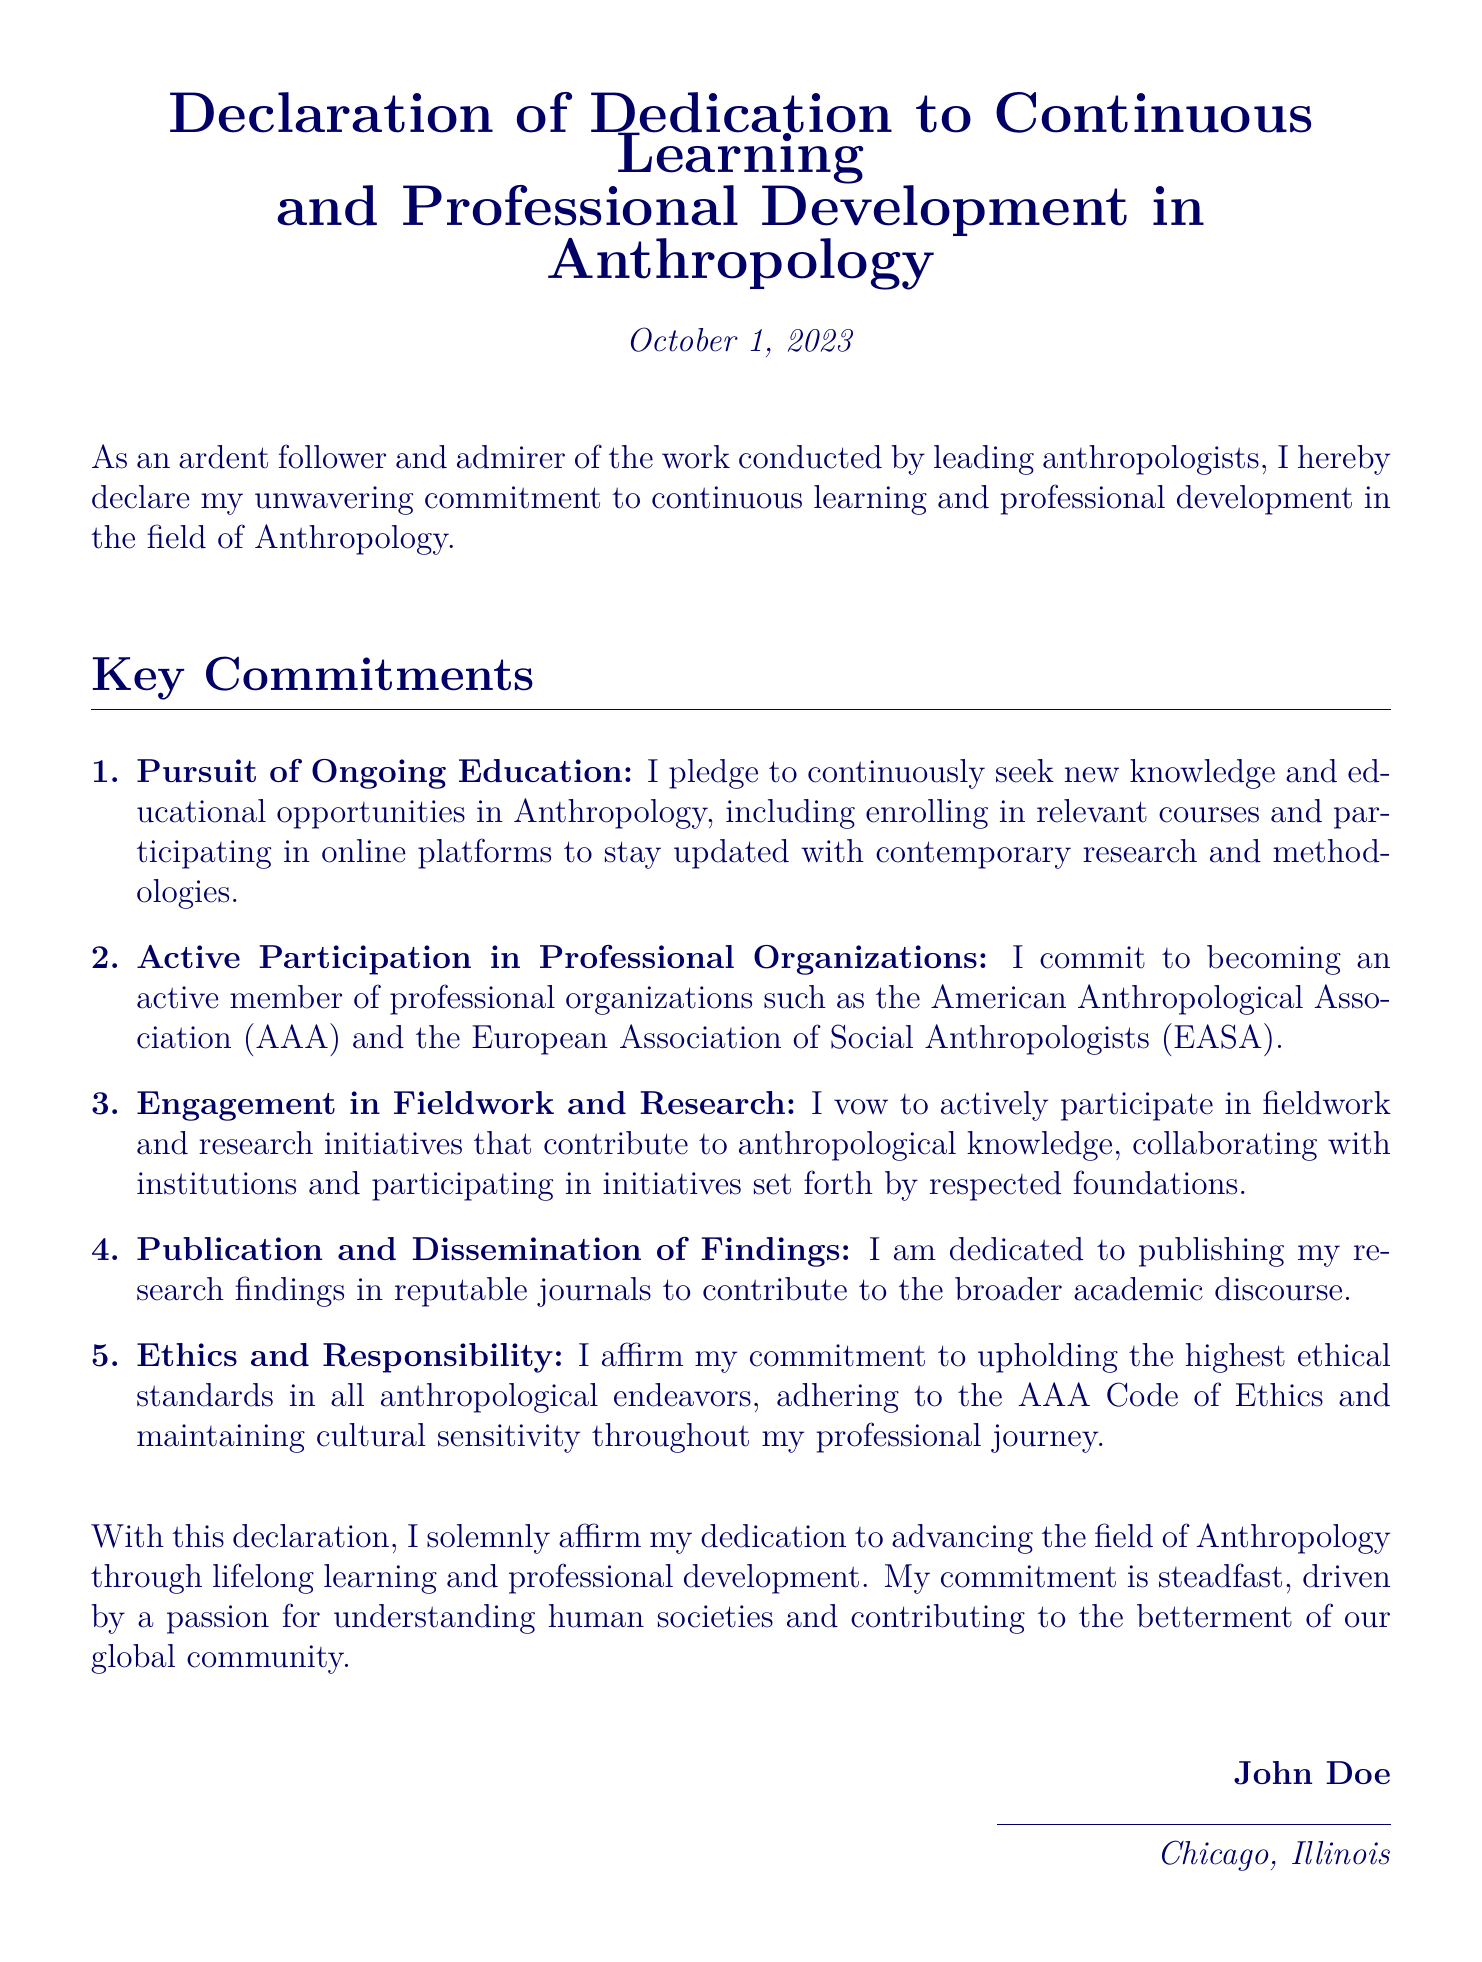What is the title of the declaration? The title is presented at the top of the document, clearly stating the commitment.
Answer: Declaration of Dedication to Continuous Learning and Professional Development in Anthropology What is the date of the declaration? The date is included below the title and indicates when the declaration was made.
Answer: October 1, 2023 Who is the declarant? The individual's name is provided at the bottom of the document, indicating who made the declaration.
Answer: John Doe What organization is mentioned as a professional association? One of the organizations mentioned is a significant body in the field of Anthropology.
Answer: American Anthropological Association (AAA) How many key commitments are listed? The number of commitments can be found in the enumeration at the beginning of the commitments section.
Answer: 5 What is the first key commitment? The first point listed under key commitments clearly outlines the focus on ongoing education.
Answer: Pursuit of Ongoing Education Which ethical standards are referenced in the document? The document specifies that the commitment relates to a particular code concerning ethical behavior in anthropology.
Answer: AAA Code of Ethics Where is the declarant located? The location of the declarant is mentioned at the end of the document, indicating their place of residence.
Answer: Chicago, Illinois What is a primary goal of the declarant according to the document? The overall purpose of the declaration relates to making a contribution to the field and society.
Answer: Advancing the field of Anthropology 